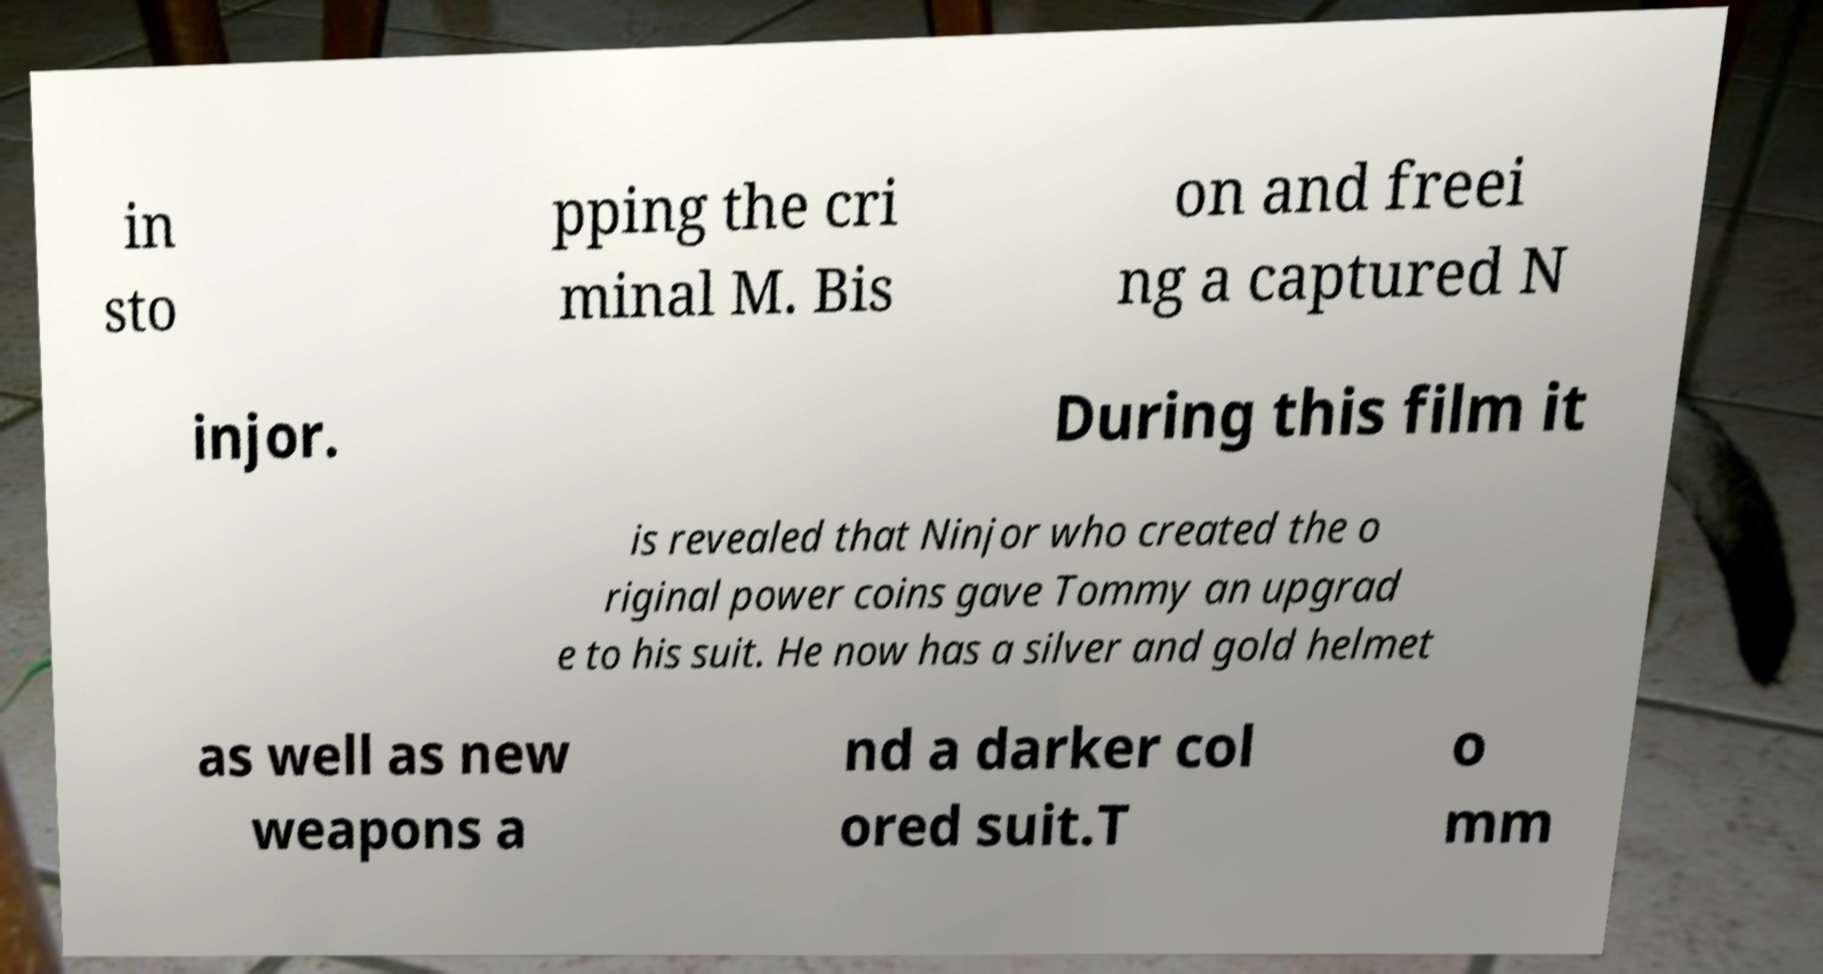Could you extract and type out the text from this image? in sto pping the cri minal M. Bis on and freei ng a captured N injor. During this film it is revealed that Ninjor who created the o riginal power coins gave Tommy an upgrad e to his suit. He now has a silver and gold helmet as well as new weapons a nd a darker col ored suit.T o mm 